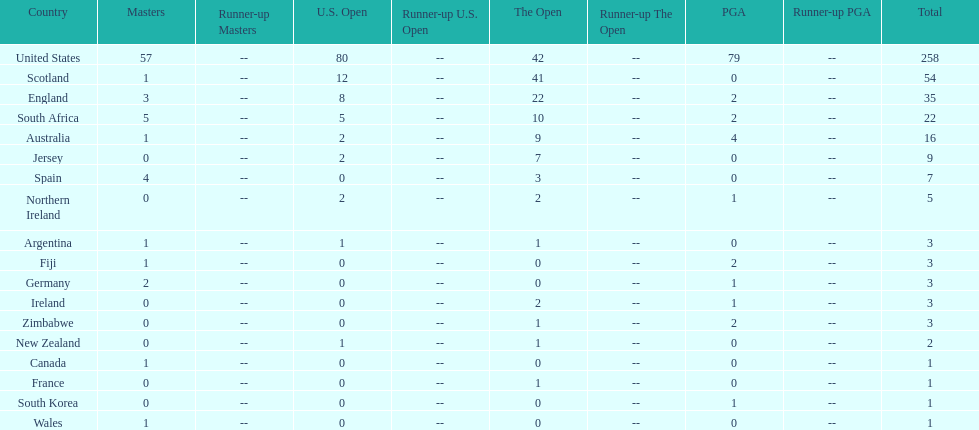Is the united stated or scotland better? United States. 